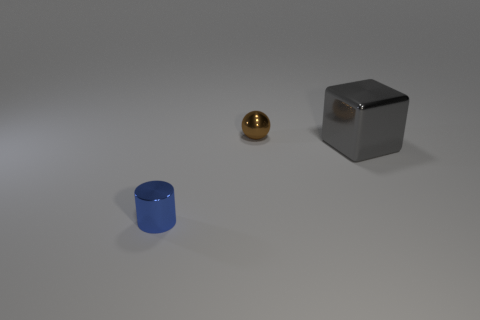There is a metallic object that is the same size as the blue shiny cylinder; what shape is it?
Your response must be concise. Sphere. There is a blue cylinder; how many gray shiny objects are behind it?
Offer a terse response. 1. Are the small sphere and the object in front of the big gray metal cube made of the same material?
Your answer should be very brief. Yes. Is the brown object made of the same material as the gray cube?
Your response must be concise. Yes. There is a metal thing that is on the left side of the sphere; are there any metallic spheres behind it?
Make the answer very short. Yes. How many tiny metallic things are in front of the gray metal thing and to the right of the cylinder?
Provide a succinct answer. 0. What shape is the small thing that is in front of the big gray cube?
Your response must be concise. Cylinder. How many blue objects are the same size as the metallic block?
Your response must be concise. 0. The thing that is both in front of the small ball and to the left of the gray metal cube is made of what material?
Provide a succinct answer. Metal. Are there more cyan metallic cylinders than tiny metallic objects?
Offer a very short reply. No. 